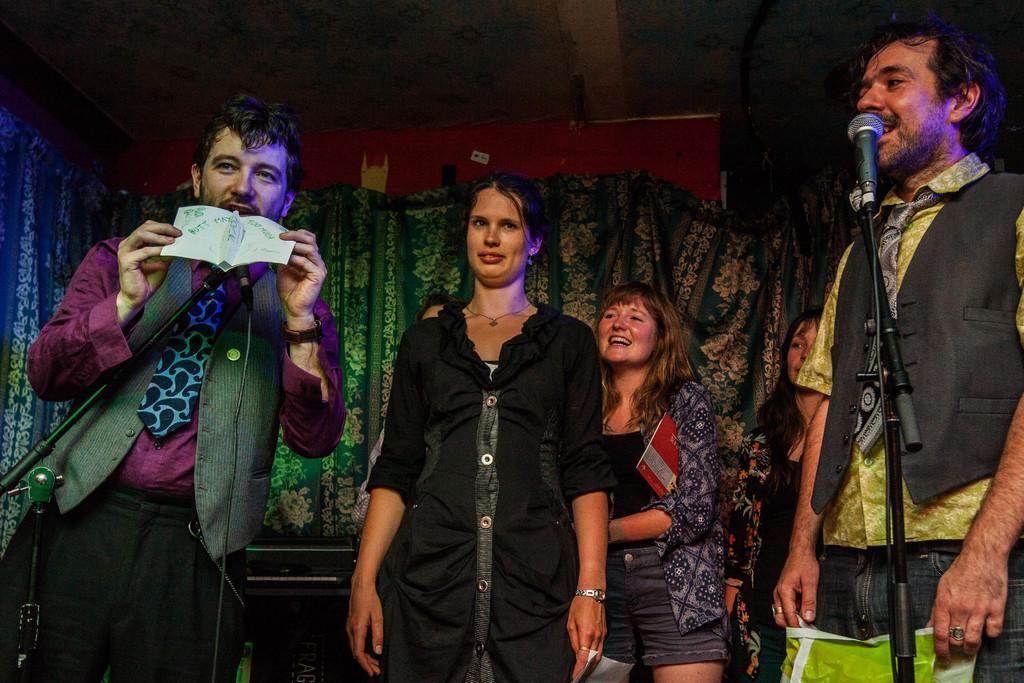In one or two sentences, can you explain what this image depicts? Man on the left corner of the picture is wearing a purple shirt and he is holding a paper in his hand. In front of him, we see the microphone. Beside him, woman in black dress is standing in the middle of the picture. Man on the right corner of the picture who is wearing a yellow t-shirt and black coat is holding the green color plastic cover in his hand and he is talking on the microphone. Behind him, there are three women standing and smiling. Behind them, we see a curtain in blue and white color and behind that, we see a red color wall. 